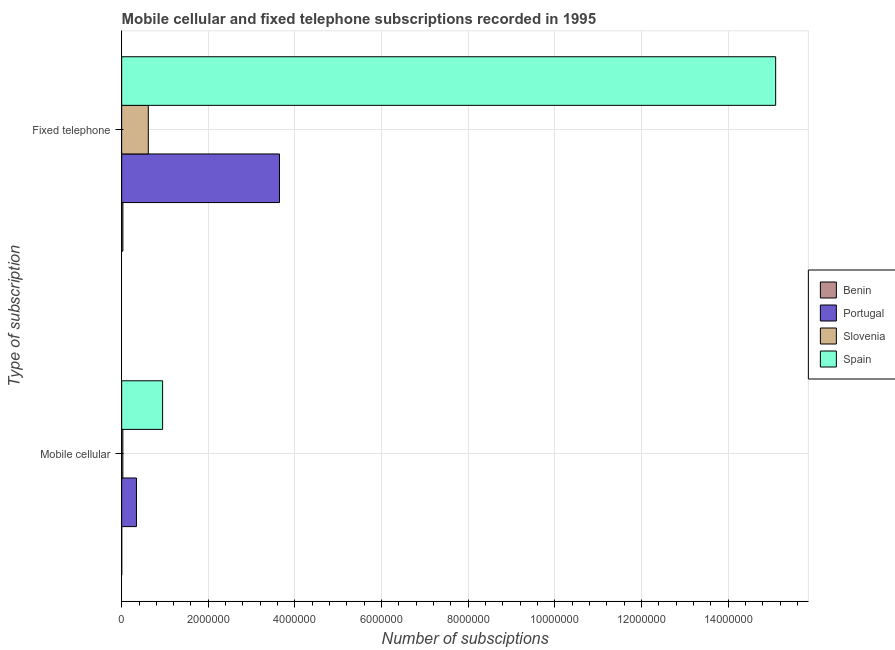What is the label of the 1st group of bars from the top?
Ensure brevity in your answer.  Fixed telephone. What is the number of mobile cellular subscriptions in Slovenia?
Offer a very short reply. 2.73e+04. Across all countries, what is the maximum number of mobile cellular subscriptions?
Ensure brevity in your answer.  9.45e+05. Across all countries, what is the minimum number of fixed telephone subscriptions?
Offer a terse response. 2.82e+04. In which country was the number of fixed telephone subscriptions maximum?
Your answer should be very brief. Spain. In which country was the number of fixed telephone subscriptions minimum?
Your response must be concise. Benin. What is the total number of mobile cellular subscriptions in the graph?
Your response must be concise. 1.31e+06. What is the difference between the number of fixed telephone subscriptions in Slovenia and that in Portugal?
Your answer should be compact. -3.03e+06. What is the difference between the number of fixed telephone subscriptions in Benin and the number of mobile cellular subscriptions in Slovenia?
Your response must be concise. 905. What is the average number of mobile cellular subscriptions per country?
Provide a short and direct response. 3.29e+05. What is the difference between the number of fixed telephone subscriptions and number of mobile cellular subscriptions in Benin?
Provide a succinct answer. 2.72e+04. In how many countries, is the number of fixed telephone subscriptions greater than 5200000 ?
Your response must be concise. 1. What is the ratio of the number of fixed telephone subscriptions in Slovenia to that in Benin?
Your response must be concise. 21.8. Is the number of mobile cellular subscriptions in Benin less than that in Slovenia?
Offer a very short reply. Yes. What does the 2nd bar from the bottom in Mobile cellular represents?
Your answer should be very brief. Portugal. How many bars are there?
Make the answer very short. 8. How many countries are there in the graph?
Make the answer very short. 4. What is the difference between two consecutive major ticks on the X-axis?
Provide a short and direct response. 2.00e+06. How many legend labels are there?
Your answer should be compact. 4. What is the title of the graph?
Your answer should be very brief. Mobile cellular and fixed telephone subscriptions recorded in 1995. What is the label or title of the X-axis?
Provide a short and direct response. Number of subsciptions. What is the label or title of the Y-axis?
Your answer should be very brief. Type of subscription. What is the Number of subsciptions in Benin in Mobile cellular?
Make the answer very short. 1050. What is the Number of subsciptions of Portugal in Mobile cellular?
Keep it short and to the point. 3.41e+05. What is the Number of subsciptions in Slovenia in Mobile cellular?
Offer a very short reply. 2.73e+04. What is the Number of subsciptions in Spain in Mobile cellular?
Your answer should be compact. 9.45e+05. What is the Number of subsciptions of Benin in Fixed telephone?
Ensure brevity in your answer.  2.82e+04. What is the Number of subsciptions in Portugal in Fixed telephone?
Ensure brevity in your answer.  3.64e+06. What is the Number of subsciptions of Slovenia in Fixed telephone?
Ensure brevity in your answer.  6.15e+05. What is the Number of subsciptions in Spain in Fixed telephone?
Your answer should be very brief. 1.51e+07. Across all Type of subscription, what is the maximum Number of subsciptions in Benin?
Keep it short and to the point. 2.82e+04. Across all Type of subscription, what is the maximum Number of subsciptions in Portugal?
Keep it short and to the point. 3.64e+06. Across all Type of subscription, what is the maximum Number of subsciptions of Slovenia?
Ensure brevity in your answer.  6.15e+05. Across all Type of subscription, what is the maximum Number of subsciptions of Spain?
Keep it short and to the point. 1.51e+07. Across all Type of subscription, what is the minimum Number of subsciptions in Benin?
Your response must be concise. 1050. Across all Type of subscription, what is the minimum Number of subsciptions of Portugal?
Offer a terse response. 3.41e+05. Across all Type of subscription, what is the minimum Number of subsciptions in Slovenia?
Make the answer very short. 2.73e+04. Across all Type of subscription, what is the minimum Number of subsciptions in Spain?
Ensure brevity in your answer.  9.45e+05. What is the total Number of subsciptions of Benin in the graph?
Give a very brief answer. 2.93e+04. What is the total Number of subsciptions of Portugal in the graph?
Keep it short and to the point. 3.98e+06. What is the total Number of subsciptions in Slovenia in the graph?
Your answer should be very brief. 6.42e+05. What is the total Number of subsciptions in Spain in the graph?
Your answer should be compact. 1.60e+07. What is the difference between the Number of subsciptions in Benin in Mobile cellular and that in Fixed telephone?
Make the answer very short. -2.72e+04. What is the difference between the Number of subsciptions in Portugal in Mobile cellular and that in Fixed telephone?
Your response must be concise. -3.30e+06. What is the difference between the Number of subsciptions of Slovenia in Mobile cellular and that in Fixed telephone?
Make the answer very short. -5.87e+05. What is the difference between the Number of subsciptions of Spain in Mobile cellular and that in Fixed telephone?
Provide a succinct answer. -1.42e+07. What is the difference between the Number of subsciptions of Benin in Mobile cellular and the Number of subsciptions of Portugal in Fixed telephone?
Give a very brief answer. -3.64e+06. What is the difference between the Number of subsciptions of Benin in Mobile cellular and the Number of subsciptions of Slovenia in Fixed telephone?
Your response must be concise. -6.14e+05. What is the difference between the Number of subsciptions of Benin in Mobile cellular and the Number of subsciptions of Spain in Fixed telephone?
Keep it short and to the point. -1.51e+07. What is the difference between the Number of subsciptions in Portugal in Mobile cellular and the Number of subsciptions in Slovenia in Fixed telephone?
Provide a succinct answer. -2.74e+05. What is the difference between the Number of subsciptions in Portugal in Mobile cellular and the Number of subsciptions in Spain in Fixed telephone?
Your answer should be compact. -1.48e+07. What is the difference between the Number of subsciptions of Slovenia in Mobile cellular and the Number of subsciptions of Spain in Fixed telephone?
Your answer should be compact. -1.51e+07. What is the average Number of subsciptions of Benin per Type of subscription?
Offer a very short reply. 1.46e+04. What is the average Number of subsciptions of Portugal per Type of subscription?
Your response must be concise. 1.99e+06. What is the average Number of subsciptions of Slovenia per Type of subscription?
Your answer should be very brief. 3.21e+05. What is the average Number of subsciptions of Spain per Type of subscription?
Keep it short and to the point. 8.02e+06. What is the difference between the Number of subsciptions in Benin and Number of subsciptions in Portugal in Mobile cellular?
Offer a terse response. -3.40e+05. What is the difference between the Number of subsciptions in Benin and Number of subsciptions in Slovenia in Mobile cellular?
Your response must be concise. -2.63e+04. What is the difference between the Number of subsciptions in Benin and Number of subsciptions in Spain in Mobile cellular?
Give a very brief answer. -9.44e+05. What is the difference between the Number of subsciptions of Portugal and Number of subsciptions of Slovenia in Mobile cellular?
Give a very brief answer. 3.14e+05. What is the difference between the Number of subsciptions of Portugal and Number of subsciptions of Spain in Mobile cellular?
Offer a terse response. -6.04e+05. What is the difference between the Number of subsciptions in Slovenia and Number of subsciptions in Spain in Mobile cellular?
Your answer should be very brief. -9.18e+05. What is the difference between the Number of subsciptions in Benin and Number of subsciptions in Portugal in Fixed telephone?
Give a very brief answer. -3.61e+06. What is the difference between the Number of subsciptions in Benin and Number of subsciptions in Slovenia in Fixed telephone?
Ensure brevity in your answer.  -5.87e+05. What is the difference between the Number of subsciptions of Benin and Number of subsciptions of Spain in Fixed telephone?
Your response must be concise. -1.51e+07. What is the difference between the Number of subsciptions of Portugal and Number of subsciptions of Slovenia in Fixed telephone?
Make the answer very short. 3.03e+06. What is the difference between the Number of subsciptions of Portugal and Number of subsciptions of Spain in Fixed telephone?
Give a very brief answer. -1.15e+07. What is the difference between the Number of subsciptions in Slovenia and Number of subsciptions in Spain in Fixed telephone?
Offer a very short reply. -1.45e+07. What is the ratio of the Number of subsciptions of Benin in Mobile cellular to that in Fixed telephone?
Your answer should be very brief. 0.04. What is the ratio of the Number of subsciptions of Portugal in Mobile cellular to that in Fixed telephone?
Provide a succinct answer. 0.09. What is the ratio of the Number of subsciptions of Slovenia in Mobile cellular to that in Fixed telephone?
Your response must be concise. 0.04. What is the ratio of the Number of subsciptions of Spain in Mobile cellular to that in Fixed telephone?
Provide a succinct answer. 0.06. What is the difference between the highest and the second highest Number of subsciptions of Benin?
Provide a short and direct response. 2.72e+04. What is the difference between the highest and the second highest Number of subsciptions of Portugal?
Provide a succinct answer. 3.30e+06. What is the difference between the highest and the second highest Number of subsciptions in Slovenia?
Provide a short and direct response. 5.87e+05. What is the difference between the highest and the second highest Number of subsciptions in Spain?
Provide a succinct answer. 1.42e+07. What is the difference between the highest and the lowest Number of subsciptions of Benin?
Give a very brief answer. 2.72e+04. What is the difference between the highest and the lowest Number of subsciptions in Portugal?
Offer a very short reply. 3.30e+06. What is the difference between the highest and the lowest Number of subsciptions in Slovenia?
Keep it short and to the point. 5.87e+05. What is the difference between the highest and the lowest Number of subsciptions in Spain?
Keep it short and to the point. 1.42e+07. 